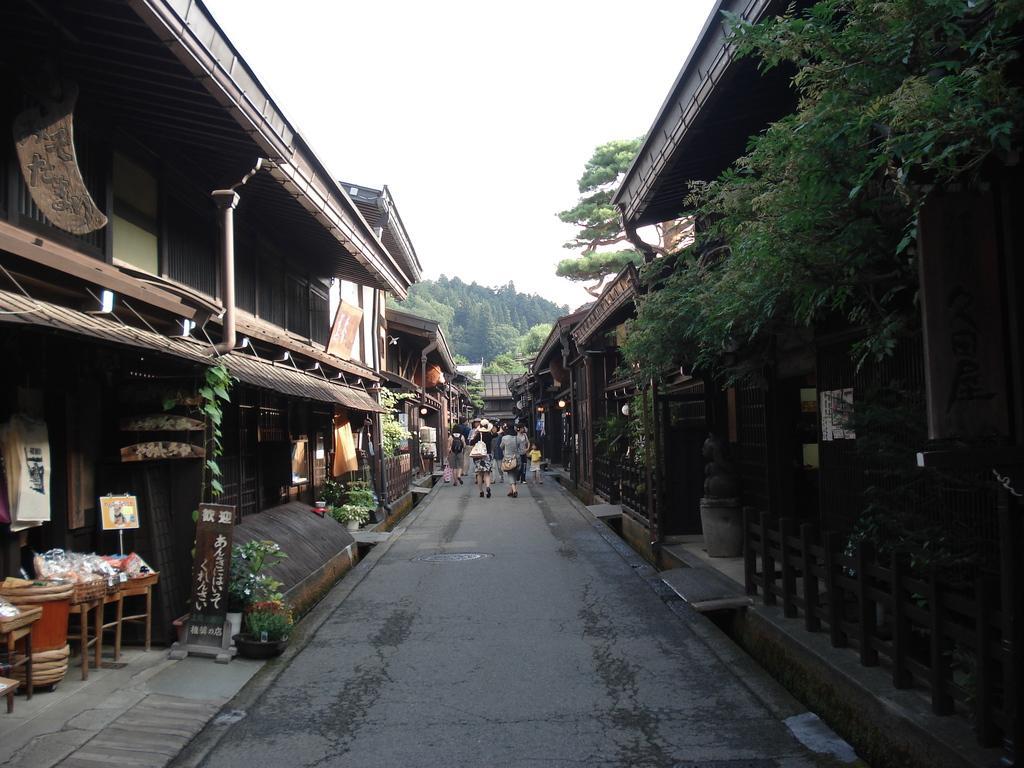In one or two sentences, can you explain what this image depicts? In this image I can see the road, few trees which are green in color, few tables with few objects on them, few persons standing on the road and few buildings on both sides of the road. In the background I can see a mountain, few trees on the mountain and the sky. 